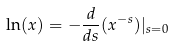<formula> <loc_0><loc_0><loc_500><loc_500>\ln ( x ) = - \frac { d } { d s } ( x ^ { - s } ) | _ { s = 0 }</formula> 